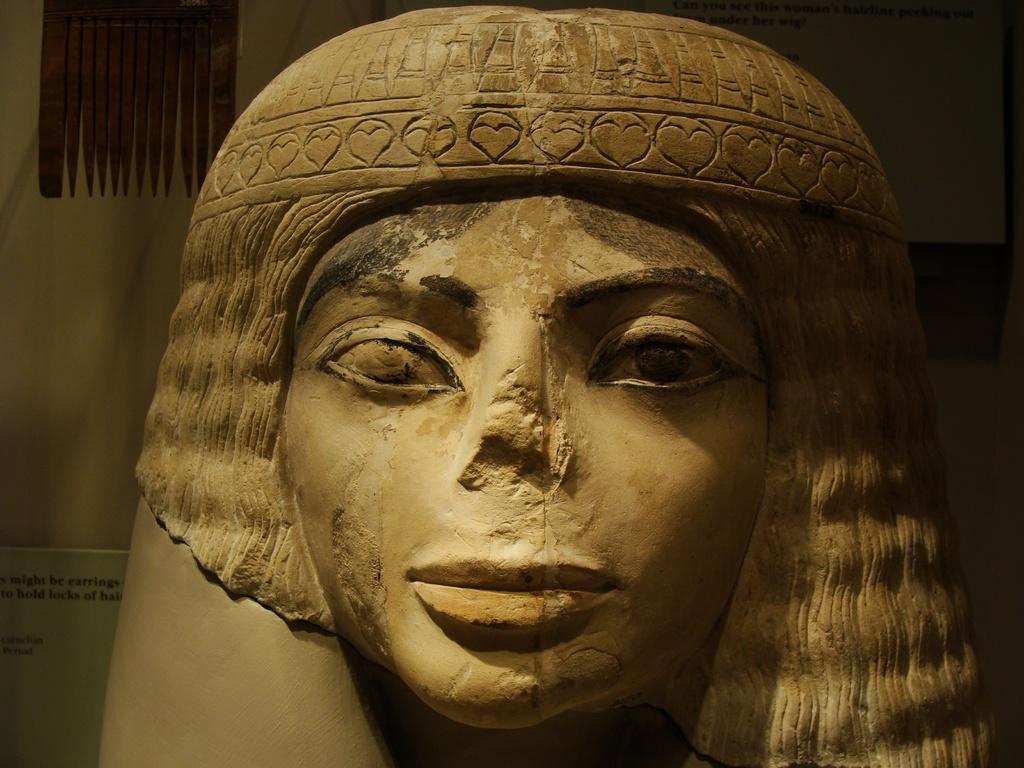Can you describe this image briefly? Here there is a sculpture of a woman. 